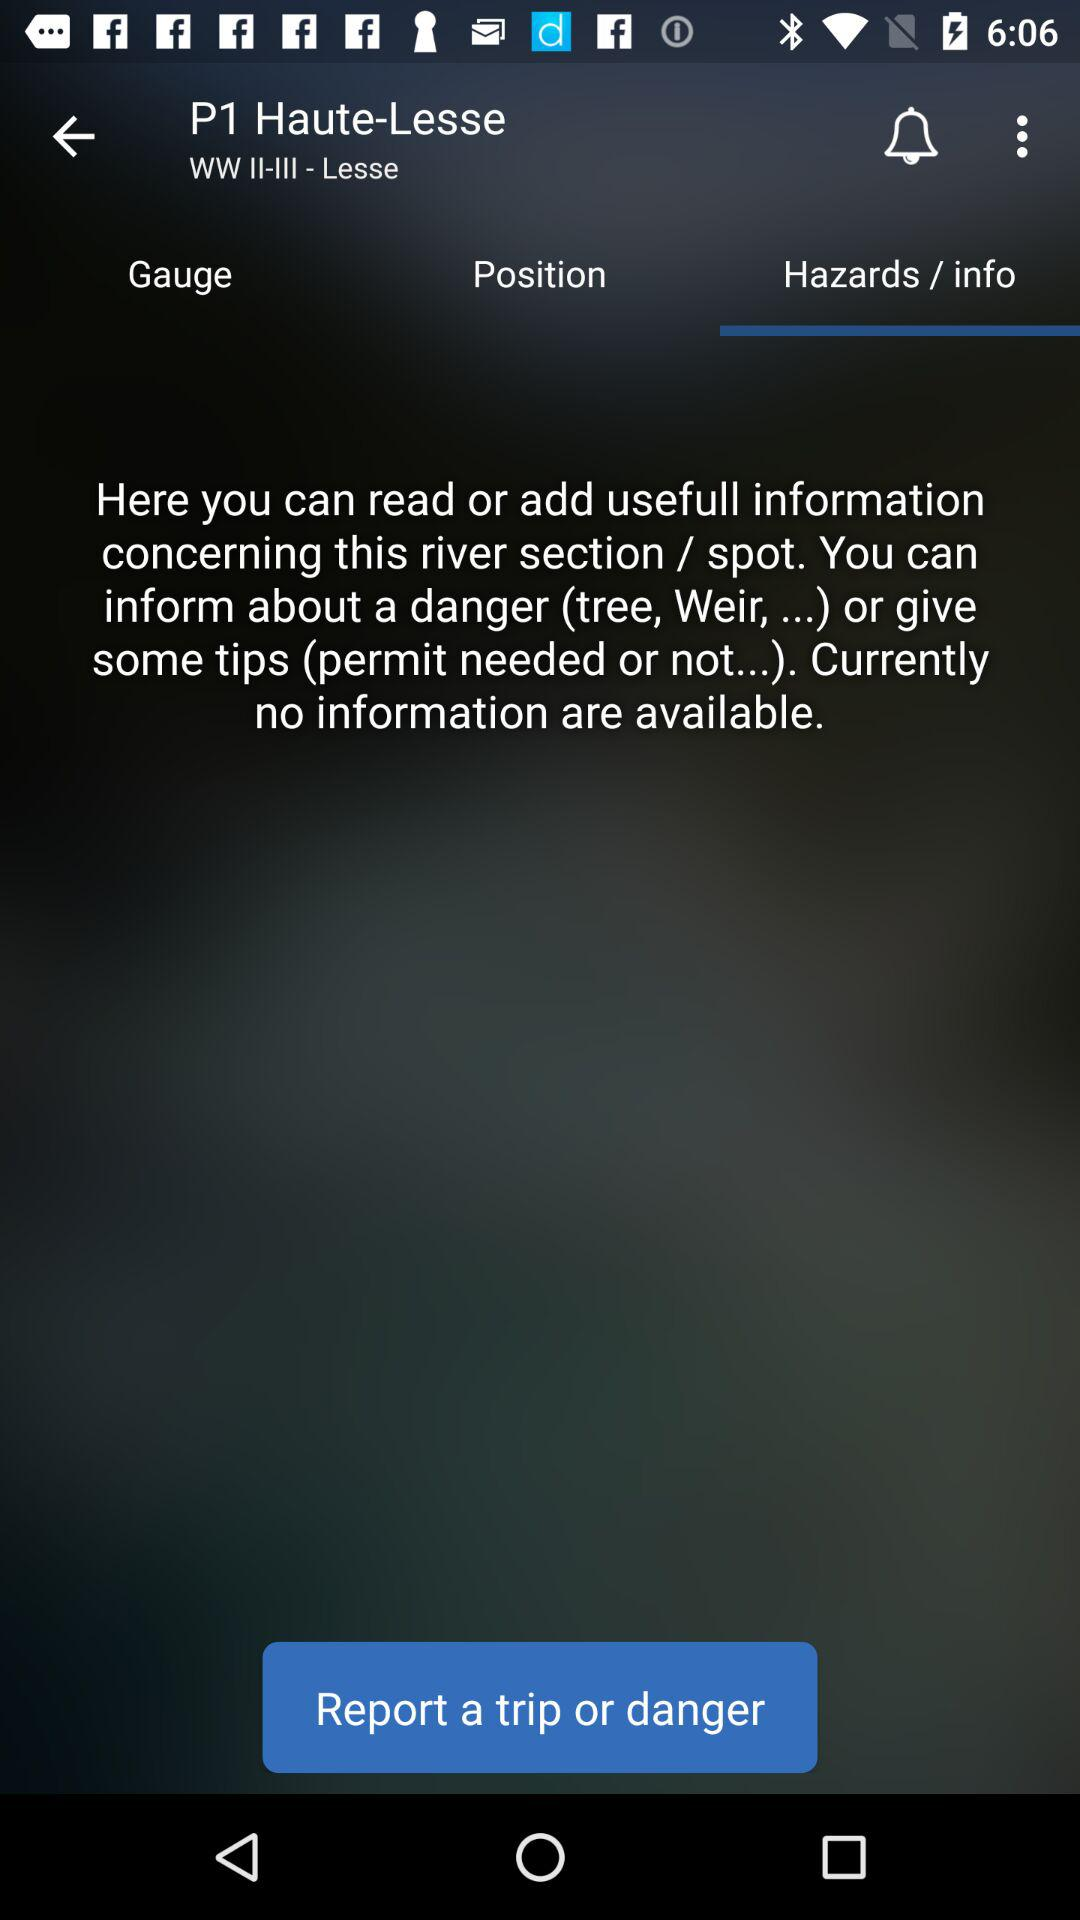How many notifications are there in "Gauge"?
When the provided information is insufficient, respond with <no answer>. <no answer> 